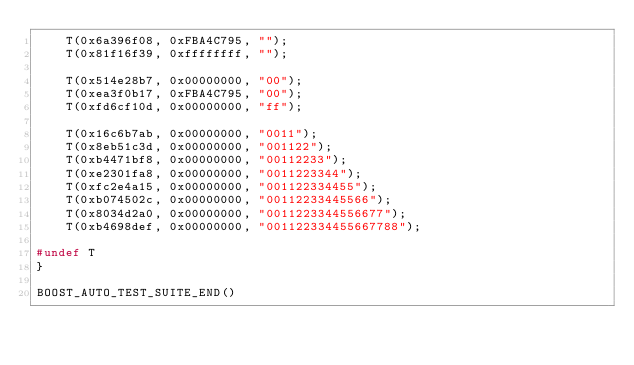<code> <loc_0><loc_0><loc_500><loc_500><_C++_>    T(0x6a396f08, 0xFBA4C795, "");
    T(0x81f16f39, 0xffffffff, "");

    T(0x514e28b7, 0x00000000, "00");
    T(0xea3f0b17, 0xFBA4C795, "00");
    T(0xfd6cf10d, 0x00000000, "ff");

    T(0x16c6b7ab, 0x00000000, "0011");
    T(0x8eb51c3d, 0x00000000, "001122");
    T(0xb4471bf8, 0x00000000, "00112233");
    T(0xe2301fa8, 0x00000000, "0011223344");
    T(0xfc2e4a15, 0x00000000, "001122334455");
    T(0xb074502c, 0x00000000, "00112233445566");
    T(0x8034d2a0, 0x00000000, "0011223344556677");
    T(0xb4698def, 0x00000000, "001122334455667788");

#undef T
}

BOOST_AUTO_TEST_SUITE_END()
</code> 